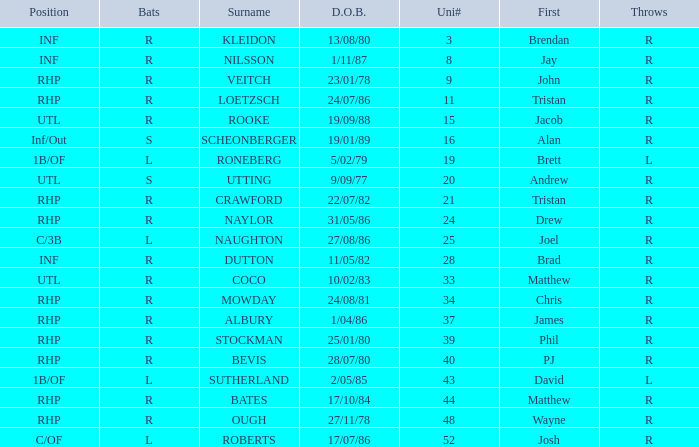Which Uni # has a Surname of ough? 48.0. Parse the table in full. {'header': ['Position', 'Bats', 'Surname', 'D.O.B.', 'Uni#', 'First', 'Throws'], 'rows': [['INF', 'R', 'KLEIDON', '13/08/80', '3', 'Brendan', 'R'], ['INF', 'R', 'NILSSON', '1/11/87', '8', 'Jay', 'R'], ['RHP', 'R', 'VEITCH', '23/01/78', '9', 'John', 'R'], ['RHP', 'R', 'LOETZSCH', '24/07/86', '11', 'Tristan', 'R'], ['UTL', 'R', 'ROOKE', '19/09/88', '15', 'Jacob', 'R'], ['Inf/Out', 'S', 'SCHEONBERGER', '19/01/89', '16', 'Alan', 'R'], ['1B/OF', 'L', 'RONEBERG', '5/02/79', '19', 'Brett', 'L'], ['UTL', 'S', 'UTTING', '9/09/77', '20', 'Andrew', 'R'], ['RHP', 'R', 'CRAWFORD', '22/07/82', '21', 'Tristan', 'R'], ['RHP', 'R', 'NAYLOR', '31/05/86', '24', 'Drew', 'R'], ['C/3B', 'L', 'NAUGHTON', '27/08/86', '25', 'Joel', 'R'], ['INF', 'R', 'DUTTON', '11/05/82', '28', 'Brad', 'R'], ['UTL', 'R', 'COCO', '10/02/83', '33', 'Matthew', 'R'], ['RHP', 'R', 'MOWDAY', '24/08/81', '34', 'Chris', 'R'], ['RHP', 'R', 'ALBURY', '1/04/86', '37', 'James', 'R'], ['RHP', 'R', 'STOCKMAN', '25/01/80', '39', 'Phil', 'R'], ['RHP', 'R', 'BEVIS', '28/07/80', '40', 'PJ', 'R'], ['1B/OF', 'L', 'SUTHERLAND', '2/05/85', '43', 'David', 'L'], ['RHP', 'R', 'BATES', '17/10/84', '44', 'Matthew', 'R'], ['RHP', 'R', 'OUGH', '27/11/78', '48', 'Wayne', 'R'], ['C/OF', 'L', 'ROBERTS', '17/07/86', '52', 'Josh', 'R']]} 